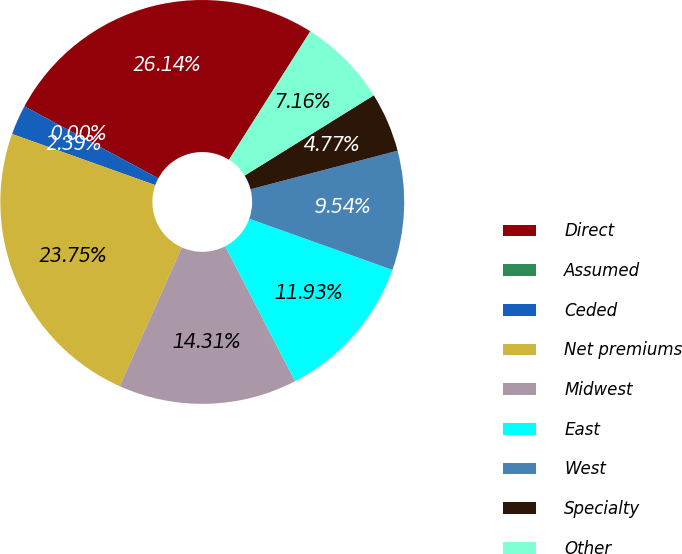Convert chart. <chart><loc_0><loc_0><loc_500><loc_500><pie_chart><fcel>Direct<fcel>Assumed<fcel>Ceded<fcel>Net premiums<fcel>Midwest<fcel>East<fcel>West<fcel>Specialty<fcel>Other<nl><fcel>26.13%<fcel>0.0%<fcel>2.39%<fcel>23.75%<fcel>14.31%<fcel>11.93%<fcel>9.54%<fcel>4.77%<fcel>7.16%<nl></chart> 